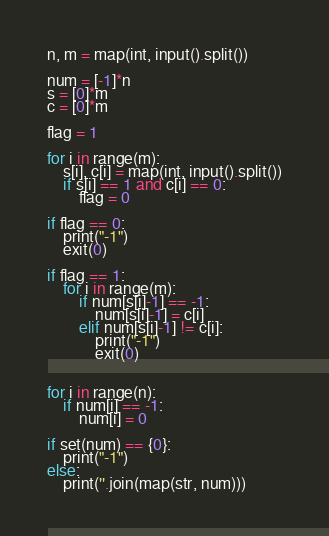Convert code to text. <code><loc_0><loc_0><loc_500><loc_500><_Python_>n, m = map(int, input().split())

num = [-1]*n
s = [0]*m
c = [0]*m

flag = 1

for i in range(m):
    s[i], c[i] = map(int, input().split())
    if s[i] == 1 and c[i] == 0:
        flag = 0

if flag == 0:
    print("-1")
    exit(0)

if flag == 1:
    for i in range(m):
        if num[s[i]-1] == -1:
            num[s[i]-1] = c[i]
        elif num[s[i]-1] != c[i]:
            print("-1")
            exit(0)


for i in range(n):
    if num[i] == -1:
        num[i] = 0

if set(num) == {0}:
    print("-1")
else:
    print(''.join(map(str, num)))
</code> 